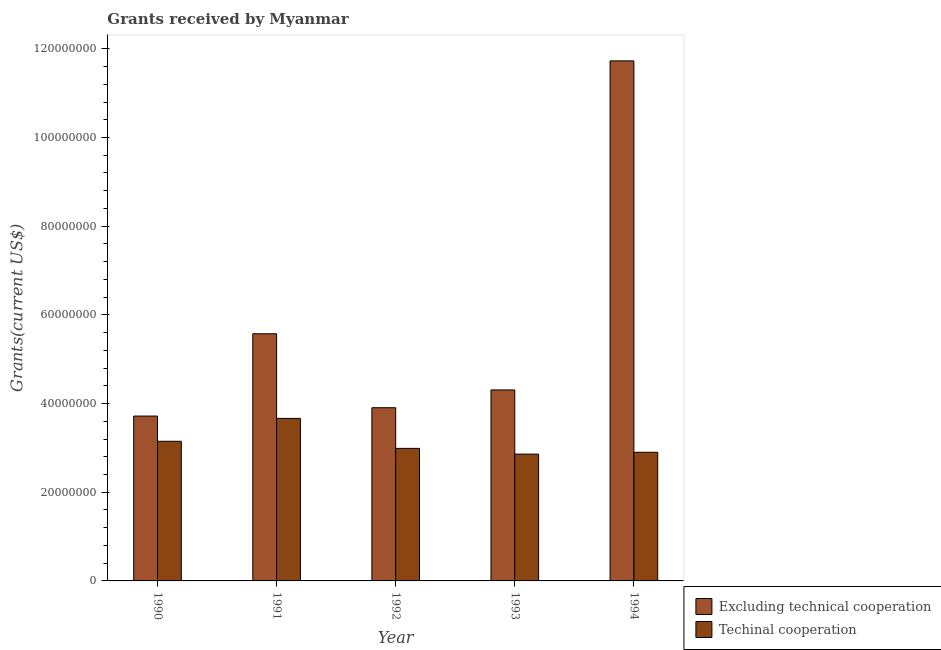Are the number of bars per tick equal to the number of legend labels?
Keep it short and to the point. Yes. How many bars are there on the 3rd tick from the left?
Give a very brief answer. 2. What is the amount of grants received(including technical cooperation) in 1993?
Your response must be concise. 2.86e+07. Across all years, what is the maximum amount of grants received(including technical cooperation)?
Offer a very short reply. 3.66e+07. Across all years, what is the minimum amount of grants received(excluding technical cooperation)?
Your answer should be compact. 3.72e+07. In which year was the amount of grants received(including technical cooperation) maximum?
Offer a very short reply. 1991. In which year was the amount of grants received(excluding technical cooperation) minimum?
Keep it short and to the point. 1990. What is the total amount of grants received(excluding technical cooperation) in the graph?
Offer a terse response. 2.92e+08. What is the difference between the amount of grants received(excluding technical cooperation) in 1993 and that in 1994?
Offer a very short reply. -7.42e+07. What is the difference between the amount of grants received(excluding technical cooperation) in 1993 and the amount of grants received(including technical cooperation) in 1992?
Your answer should be very brief. 4.01e+06. What is the average amount of grants received(excluding technical cooperation) per year?
Your answer should be very brief. 5.85e+07. What is the ratio of the amount of grants received(excluding technical cooperation) in 1990 to that in 1992?
Provide a short and direct response. 0.95. Is the difference between the amount of grants received(including technical cooperation) in 1992 and 1994 greater than the difference between the amount of grants received(excluding technical cooperation) in 1992 and 1994?
Offer a terse response. No. What is the difference between the highest and the second highest amount of grants received(including technical cooperation)?
Keep it short and to the point. 5.16e+06. What is the difference between the highest and the lowest amount of grants received(excluding technical cooperation)?
Provide a short and direct response. 8.01e+07. Is the sum of the amount of grants received(including technical cooperation) in 1991 and 1992 greater than the maximum amount of grants received(excluding technical cooperation) across all years?
Give a very brief answer. Yes. What does the 1st bar from the left in 1993 represents?
Your answer should be compact. Excluding technical cooperation. What does the 2nd bar from the right in 1991 represents?
Give a very brief answer. Excluding technical cooperation. How many bars are there?
Provide a succinct answer. 10. Are all the bars in the graph horizontal?
Provide a short and direct response. No. Are the values on the major ticks of Y-axis written in scientific E-notation?
Offer a terse response. No. How are the legend labels stacked?
Provide a succinct answer. Vertical. What is the title of the graph?
Keep it short and to the point. Grants received by Myanmar. Does "Male population" appear as one of the legend labels in the graph?
Offer a terse response. No. What is the label or title of the X-axis?
Offer a terse response. Year. What is the label or title of the Y-axis?
Your answer should be very brief. Grants(current US$). What is the Grants(current US$) in Excluding technical cooperation in 1990?
Your response must be concise. 3.72e+07. What is the Grants(current US$) in Techinal cooperation in 1990?
Provide a short and direct response. 3.15e+07. What is the Grants(current US$) in Excluding technical cooperation in 1991?
Make the answer very short. 5.57e+07. What is the Grants(current US$) in Techinal cooperation in 1991?
Provide a short and direct response. 3.66e+07. What is the Grants(current US$) of Excluding technical cooperation in 1992?
Offer a very short reply. 3.91e+07. What is the Grants(current US$) in Techinal cooperation in 1992?
Provide a short and direct response. 2.99e+07. What is the Grants(current US$) in Excluding technical cooperation in 1993?
Offer a terse response. 4.31e+07. What is the Grants(current US$) of Techinal cooperation in 1993?
Give a very brief answer. 2.86e+07. What is the Grants(current US$) in Excluding technical cooperation in 1994?
Ensure brevity in your answer.  1.17e+08. What is the Grants(current US$) in Techinal cooperation in 1994?
Offer a very short reply. 2.90e+07. Across all years, what is the maximum Grants(current US$) in Excluding technical cooperation?
Offer a very short reply. 1.17e+08. Across all years, what is the maximum Grants(current US$) in Techinal cooperation?
Give a very brief answer. 3.66e+07. Across all years, what is the minimum Grants(current US$) of Excluding technical cooperation?
Offer a very short reply. 3.72e+07. Across all years, what is the minimum Grants(current US$) of Techinal cooperation?
Your answer should be compact. 2.86e+07. What is the total Grants(current US$) of Excluding technical cooperation in the graph?
Offer a very short reply. 2.92e+08. What is the total Grants(current US$) in Techinal cooperation in the graph?
Offer a terse response. 1.56e+08. What is the difference between the Grants(current US$) of Excluding technical cooperation in 1990 and that in 1991?
Ensure brevity in your answer.  -1.86e+07. What is the difference between the Grants(current US$) of Techinal cooperation in 1990 and that in 1991?
Give a very brief answer. -5.16e+06. What is the difference between the Grants(current US$) in Excluding technical cooperation in 1990 and that in 1992?
Ensure brevity in your answer.  -1.88e+06. What is the difference between the Grants(current US$) of Techinal cooperation in 1990 and that in 1992?
Provide a short and direct response. 1.60e+06. What is the difference between the Grants(current US$) of Excluding technical cooperation in 1990 and that in 1993?
Make the answer very short. -5.89e+06. What is the difference between the Grants(current US$) of Techinal cooperation in 1990 and that in 1993?
Ensure brevity in your answer.  2.89e+06. What is the difference between the Grants(current US$) in Excluding technical cooperation in 1990 and that in 1994?
Your response must be concise. -8.01e+07. What is the difference between the Grants(current US$) of Techinal cooperation in 1990 and that in 1994?
Your response must be concise. 2.48e+06. What is the difference between the Grants(current US$) of Excluding technical cooperation in 1991 and that in 1992?
Give a very brief answer. 1.67e+07. What is the difference between the Grants(current US$) of Techinal cooperation in 1991 and that in 1992?
Offer a very short reply. 6.76e+06. What is the difference between the Grants(current US$) of Excluding technical cooperation in 1991 and that in 1993?
Provide a short and direct response. 1.27e+07. What is the difference between the Grants(current US$) of Techinal cooperation in 1991 and that in 1993?
Your answer should be very brief. 8.05e+06. What is the difference between the Grants(current US$) of Excluding technical cooperation in 1991 and that in 1994?
Ensure brevity in your answer.  -6.15e+07. What is the difference between the Grants(current US$) in Techinal cooperation in 1991 and that in 1994?
Ensure brevity in your answer.  7.64e+06. What is the difference between the Grants(current US$) of Excluding technical cooperation in 1992 and that in 1993?
Ensure brevity in your answer.  -4.01e+06. What is the difference between the Grants(current US$) of Techinal cooperation in 1992 and that in 1993?
Provide a short and direct response. 1.29e+06. What is the difference between the Grants(current US$) of Excluding technical cooperation in 1992 and that in 1994?
Offer a very short reply. -7.82e+07. What is the difference between the Grants(current US$) of Techinal cooperation in 1992 and that in 1994?
Offer a terse response. 8.80e+05. What is the difference between the Grants(current US$) of Excluding technical cooperation in 1993 and that in 1994?
Provide a short and direct response. -7.42e+07. What is the difference between the Grants(current US$) of Techinal cooperation in 1993 and that in 1994?
Keep it short and to the point. -4.10e+05. What is the difference between the Grants(current US$) in Excluding technical cooperation in 1990 and the Grants(current US$) in Techinal cooperation in 1991?
Provide a short and direct response. 5.30e+05. What is the difference between the Grants(current US$) in Excluding technical cooperation in 1990 and the Grants(current US$) in Techinal cooperation in 1992?
Provide a short and direct response. 7.29e+06. What is the difference between the Grants(current US$) in Excluding technical cooperation in 1990 and the Grants(current US$) in Techinal cooperation in 1993?
Give a very brief answer. 8.58e+06. What is the difference between the Grants(current US$) in Excluding technical cooperation in 1990 and the Grants(current US$) in Techinal cooperation in 1994?
Ensure brevity in your answer.  8.17e+06. What is the difference between the Grants(current US$) of Excluding technical cooperation in 1991 and the Grants(current US$) of Techinal cooperation in 1992?
Ensure brevity in your answer.  2.58e+07. What is the difference between the Grants(current US$) in Excluding technical cooperation in 1991 and the Grants(current US$) in Techinal cooperation in 1993?
Keep it short and to the point. 2.71e+07. What is the difference between the Grants(current US$) of Excluding technical cooperation in 1991 and the Grants(current US$) of Techinal cooperation in 1994?
Offer a terse response. 2.67e+07. What is the difference between the Grants(current US$) in Excluding technical cooperation in 1992 and the Grants(current US$) in Techinal cooperation in 1993?
Provide a succinct answer. 1.05e+07. What is the difference between the Grants(current US$) in Excluding technical cooperation in 1992 and the Grants(current US$) in Techinal cooperation in 1994?
Provide a short and direct response. 1.00e+07. What is the difference between the Grants(current US$) in Excluding technical cooperation in 1993 and the Grants(current US$) in Techinal cooperation in 1994?
Make the answer very short. 1.41e+07. What is the average Grants(current US$) of Excluding technical cooperation per year?
Make the answer very short. 5.85e+07. What is the average Grants(current US$) in Techinal cooperation per year?
Provide a short and direct response. 3.11e+07. In the year 1990, what is the difference between the Grants(current US$) of Excluding technical cooperation and Grants(current US$) of Techinal cooperation?
Ensure brevity in your answer.  5.69e+06. In the year 1991, what is the difference between the Grants(current US$) in Excluding technical cooperation and Grants(current US$) in Techinal cooperation?
Your answer should be very brief. 1.91e+07. In the year 1992, what is the difference between the Grants(current US$) in Excluding technical cooperation and Grants(current US$) in Techinal cooperation?
Give a very brief answer. 9.17e+06. In the year 1993, what is the difference between the Grants(current US$) in Excluding technical cooperation and Grants(current US$) in Techinal cooperation?
Your answer should be very brief. 1.45e+07. In the year 1994, what is the difference between the Grants(current US$) of Excluding technical cooperation and Grants(current US$) of Techinal cooperation?
Give a very brief answer. 8.83e+07. What is the ratio of the Grants(current US$) in Excluding technical cooperation in 1990 to that in 1991?
Give a very brief answer. 0.67. What is the ratio of the Grants(current US$) of Techinal cooperation in 1990 to that in 1991?
Your answer should be compact. 0.86. What is the ratio of the Grants(current US$) in Excluding technical cooperation in 1990 to that in 1992?
Offer a terse response. 0.95. What is the ratio of the Grants(current US$) in Techinal cooperation in 1990 to that in 1992?
Make the answer very short. 1.05. What is the ratio of the Grants(current US$) of Excluding technical cooperation in 1990 to that in 1993?
Offer a terse response. 0.86. What is the ratio of the Grants(current US$) in Techinal cooperation in 1990 to that in 1993?
Ensure brevity in your answer.  1.1. What is the ratio of the Grants(current US$) of Excluding technical cooperation in 1990 to that in 1994?
Keep it short and to the point. 0.32. What is the ratio of the Grants(current US$) in Techinal cooperation in 1990 to that in 1994?
Your response must be concise. 1.09. What is the ratio of the Grants(current US$) in Excluding technical cooperation in 1991 to that in 1992?
Keep it short and to the point. 1.43. What is the ratio of the Grants(current US$) in Techinal cooperation in 1991 to that in 1992?
Keep it short and to the point. 1.23. What is the ratio of the Grants(current US$) of Excluding technical cooperation in 1991 to that in 1993?
Offer a terse response. 1.29. What is the ratio of the Grants(current US$) in Techinal cooperation in 1991 to that in 1993?
Give a very brief answer. 1.28. What is the ratio of the Grants(current US$) of Excluding technical cooperation in 1991 to that in 1994?
Provide a succinct answer. 0.48. What is the ratio of the Grants(current US$) in Techinal cooperation in 1991 to that in 1994?
Make the answer very short. 1.26. What is the ratio of the Grants(current US$) in Excluding technical cooperation in 1992 to that in 1993?
Provide a succinct answer. 0.91. What is the ratio of the Grants(current US$) in Techinal cooperation in 1992 to that in 1993?
Your response must be concise. 1.05. What is the ratio of the Grants(current US$) in Excluding technical cooperation in 1992 to that in 1994?
Your answer should be very brief. 0.33. What is the ratio of the Grants(current US$) in Techinal cooperation in 1992 to that in 1994?
Provide a succinct answer. 1.03. What is the ratio of the Grants(current US$) of Excluding technical cooperation in 1993 to that in 1994?
Provide a succinct answer. 0.37. What is the ratio of the Grants(current US$) of Techinal cooperation in 1993 to that in 1994?
Provide a short and direct response. 0.99. What is the difference between the highest and the second highest Grants(current US$) of Excluding technical cooperation?
Keep it short and to the point. 6.15e+07. What is the difference between the highest and the second highest Grants(current US$) of Techinal cooperation?
Keep it short and to the point. 5.16e+06. What is the difference between the highest and the lowest Grants(current US$) of Excluding technical cooperation?
Your answer should be very brief. 8.01e+07. What is the difference between the highest and the lowest Grants(current US$) in Techinal cooperation?
Your answer should be compact. 8.05e+06. 